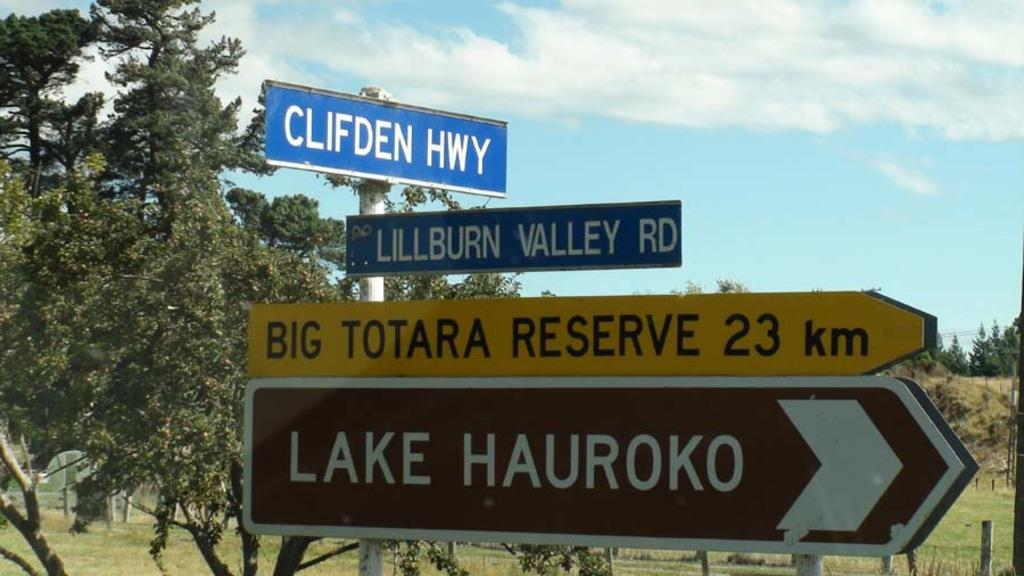<image>
Provide a brief description of the given image. Underneath two street signs at an intersection are two other signs pointing towards Big Totara Reserve and Lake Hauroko. 